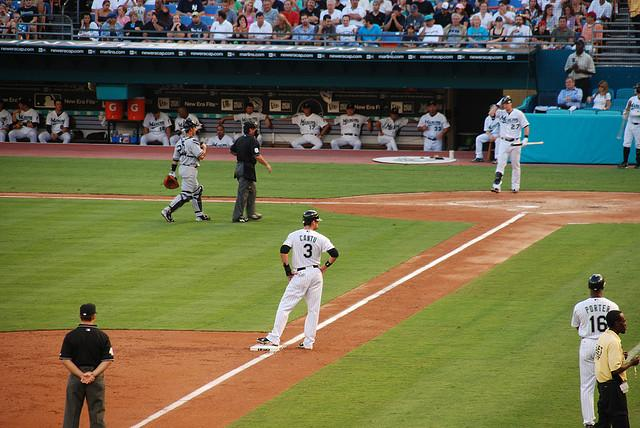What's the area where players are seated on a bench near gatorade coolers? dugout 